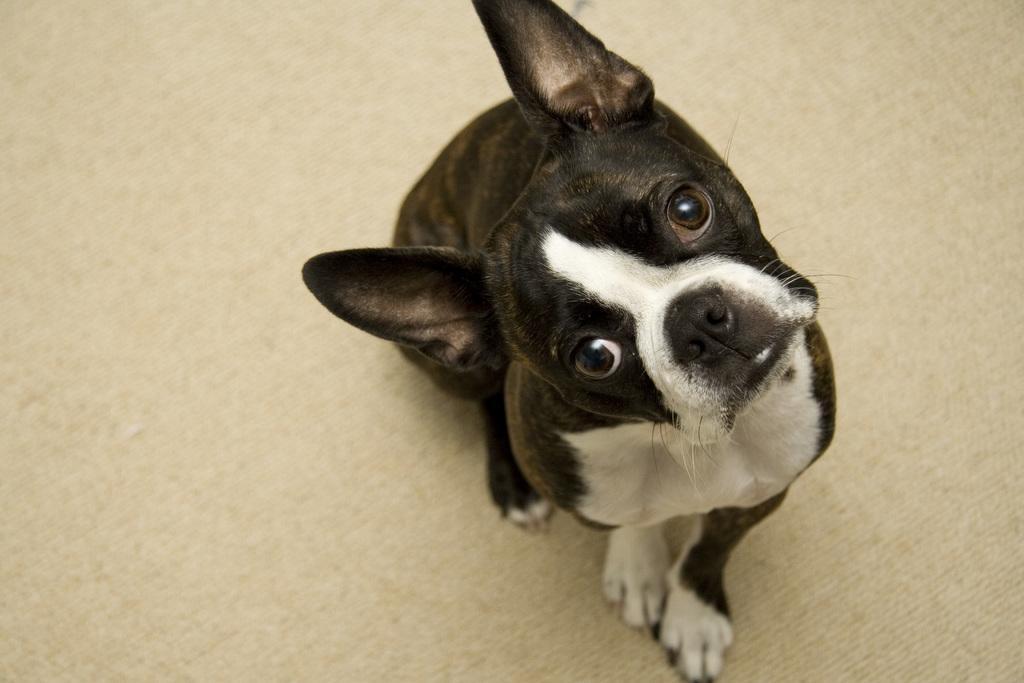In one or two sentences, can you explain what this image depicts? In this image in the foreground there is one dog, and at the bottom there is a floor. 